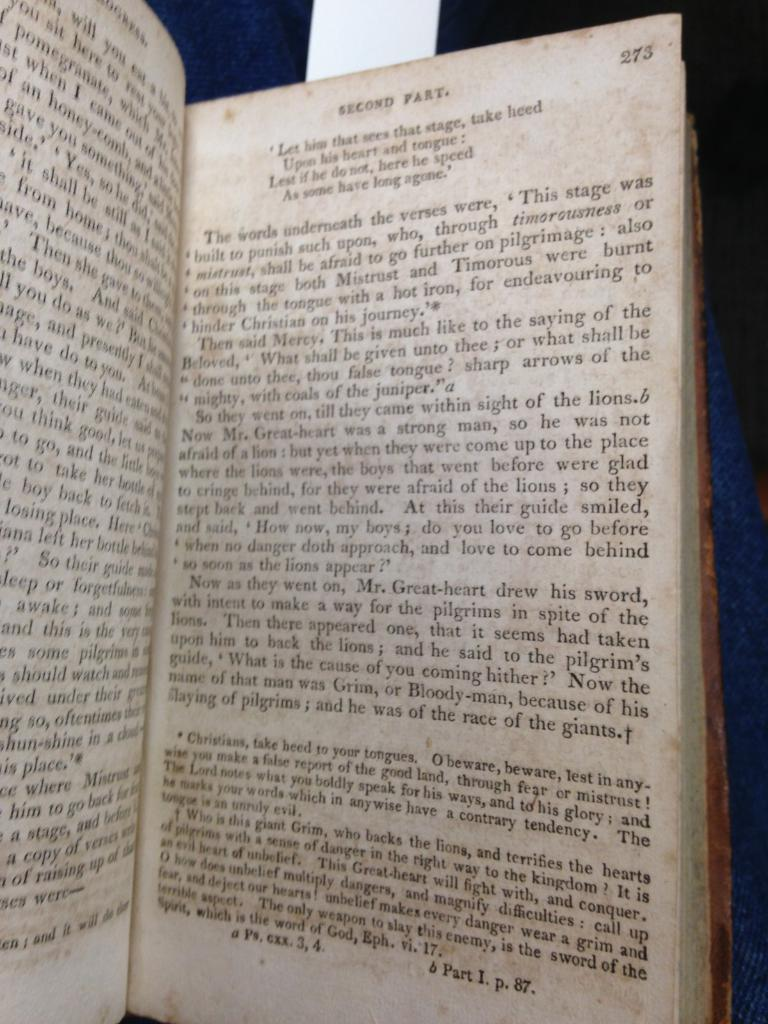<image>
Write a terse but informative summary of the picture. A chapter booklet which is the second part about the pilgrims 